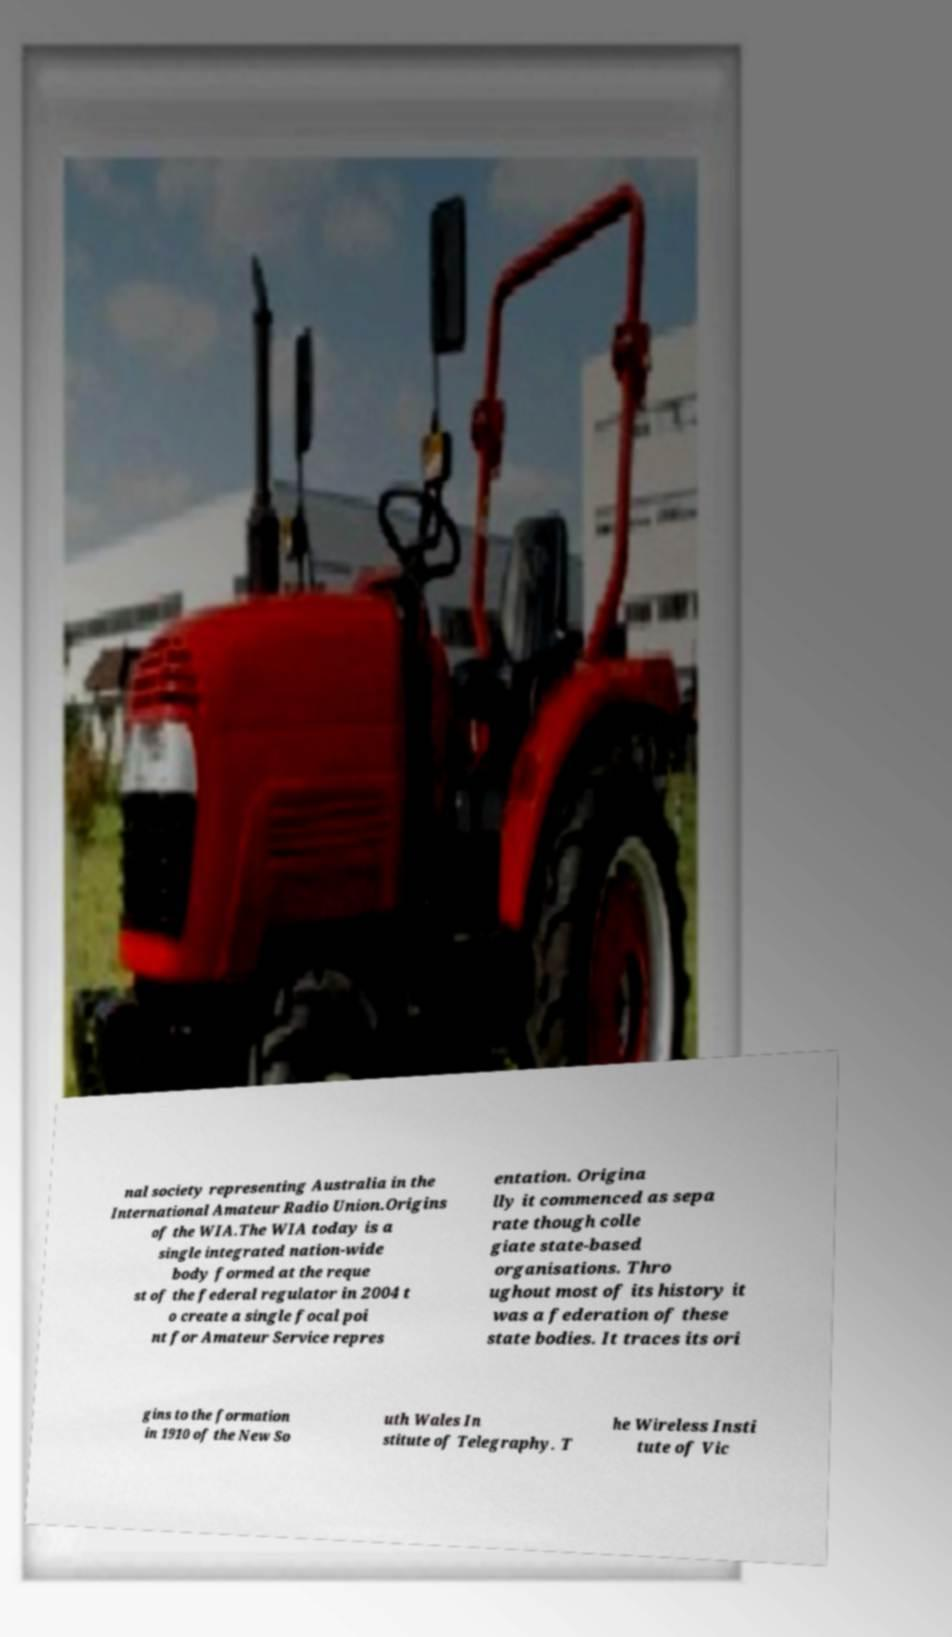I need the written content from this picture converted into text. Can you do that? nal society representing Australia in the International Amateur Radio Union.Origins of the WIA.The WIA today is a single integrated nation-wide body formed at the reque st of the federal regulator in 2004 t o create a single focal poi nt for Amateur Service repres entation. Origina lly it commenced as sepa rate though colle giate state-based organisations. Thro ughout most of its history it was a federation of these state bodies. It traces its ori gins to the formation in 1910 of the New So uth Wales In stitute of Telegraphy. T he Wireless Insti tute of Vic 